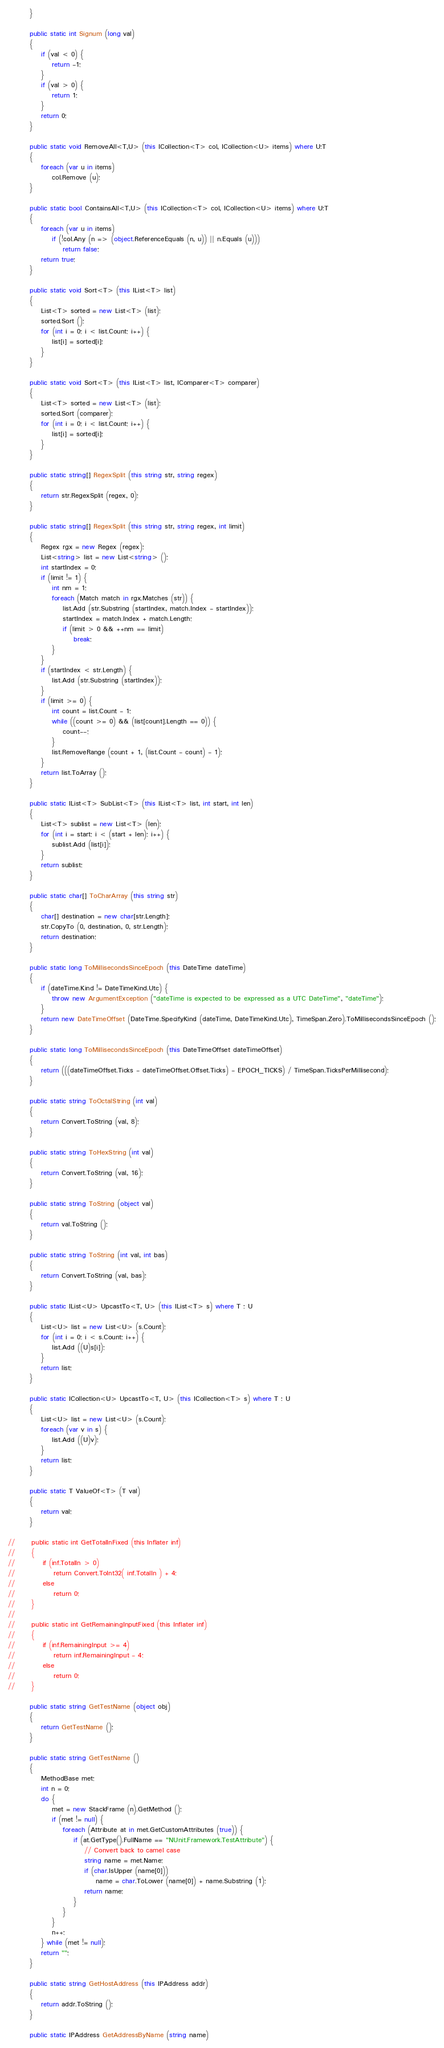Convert code to text. <code><loc_0><loc_0><loc_500><loc_500><_C#_>        }

        public static int Signum (long val)
        {
            if (val < 0) {
                return -1;
            }
            if (val > 0) {
                return 1;
            }
            return 0;
        }
        
        public static void RemoveAll<T,U> (this ICollection<T> col, ICollection<U> items) where U:T
        {
            foreach (var u in items)
                col.Remove (u);
        }

        public static bool ContainsAll<T,U> (this ICollection<T> col, ICollection<U> items) where U:T
        {
            foreach (var u in items)
                if (!col.Any (n => (object.ReferenceEquals (n, u)) || n.Equals (u)))
                    return false;
            return true;
        }

        public static void Sort<T> (this IList<T> list)
        {
            List<T> sorted = new List<T> (list);
            sorted.Sort ();
            for (int i = 0; i < list.Count; i++) {
                list[i] = sorted[i];
            }
        }

        public static void Sort<T> (this IList<T> list, IComparer<T> comparer)
        {
            List<T> sorted = new List<T> (list);
            sorted.Sort (comparer);
            for (int i = 0; i < list.Count; i++) {
                list[i] = sorted[i];
            }
        }

        public static string[] RegexSplit (this string str, string regex)
        {
            return str.RegexSplit (regex, 0);
        }
        
        public static string[] RegexSplit (this string str, string regex, int limit)
        {
            Regex rgx = new Regex (regex);
            List<string> list = new List<string> ();
            int startIndex = 0;
            if (limit != 1) {
                int nm = 1;
                foreach (Match match in rgx.Matches (str)) {
                    list.Add (str.Substring (startIndex, match.Index - startIndex));
                    startIndex = match.Index + match.Length;
                    if (limit > 0 && ++nm == limit)
                        break;
                }
            }
            if (startIndex < str.Length) {
                list.Add (str.Substring (startIndex));
            }
            if (limit >= 0) {
                int count = list.Count - 1;
                while ((count >= 0) && (list[count].Length == 0)) {
                    count--;
                }
                list.RemoveRange (count + 1, (list.Count - count) - 1);
            }
            return list.ToArray ();
        }

        public static IList<T> SubList<T> (this IList<T> list, int start, int len)
        {
            List<T> sublist = new List<T> (len);
            for (int i = start; i < (start + len); i++) {
                sublist.Add (list[i]);
            }
            return sublist;
        }

        public static char[] ToCharArray (this string str)
        {
            char[] destination = new char[str.Length];
            str.CopyTo (0, destination, 0, str.Length);
            return destination;
        }

        public static long ToMillisecondsSinceEpoch (this DateTime dateTime)
        {
            if (dateTime.Kind != DateTimeKind.Utc) {
                throw new ArgumentException ("dateTime is expected to be expressed as a UTC DateTime", "dateTime");
            }
            return new DateTimeOffset (DateTime.SpecifyKind (dateTime, DateTimeKind.Utc), TimeSpan.Zero).ToMillisecondsSinceEpoch ();
        }

        public static long ToMillisecondsSinceEpoch (this DateTimeOffset dateTimeOffset)
        {
            return (((dateTimeOffset.Ticks - dateTimeOffset.Offset.Ticks) - EPOCH_TICKS) / TimeSpan.TicksPerMillisecond);
        }

        public static string ToOctalString (int val)
        {
            return Convert.ToString (val, 8);
        }

        public static string ToHexString (int val)
        {
            return Convert.ToString (val, 16);
        }

        public static string ToString (object val)
        {
            return val.ToString ();
        }

        public static string ToString (int val, int bas)
        {
            return Convert.ToString (val, bas);
        }

        public static IList<U> UpcastTo<T, U> (this IList<T> s) where T : U
        {
            List<U> list = new List<U> (s.Count);
            for (int i = 0; i < s.Count; i++) {
                list.Add ((U)s[i]);
            }
            return list;
        }

        public static ICollection<U> UpcastTo<T, U> (this ICollection<T> s) where T : U
        {
            List<U> list = new List<U> (s.Count);
            foreach (var v in s) {
                list.Add ((U)v);
            }
            return list;
        }

        public static T ValueOf<T> (T val)
        {
            return val;
        }

//      public static int GetTotalInFixed (this Inflater inf)
//      {
//          if (inf.TotalIn > 0)
//              return Convert.ToInt32( inf.TotalIn ) + 4;
//          else
//              return 0;
//      }
//      
//      public static int GetRemainingInputFixed (this Inflater inf)
//      {
//          if (inf.RemainingInput >= 4)
//              return inf.RemainingInput - 4;
//          else
//              return 0;
//      }
        
        public static string GetTestName (object obj)
        {
            return GetTestName ();
        }
        
        public static string GetTestName ()
        {
            MethodBase met;
            int n = 0;
            do {
                met = new StackFrame (n).GetMethod ();
                if (met != null) {
                    foreach (Attribute at in met.GetCustomAttributes (true)) {
                        if (at.GetType().FullName == "NUnit.Framework.TestAttribute") {
                            // Convert back to camel case
                            string name = met.Name;
                            if (char.IsUpper (name[0]))
                                name = char.ToLower (name[0]) + name.Substring (1);
                            return name;
                        }
                    }
                }
                n++;
            } while (met != null);
            return "";
        }
        
        public static string GetHostAddress (this IPAddress addr)
        {
            return addr.ToString ();
        }
        
        public static IPAddress GetAddressByName (string name)</code> 